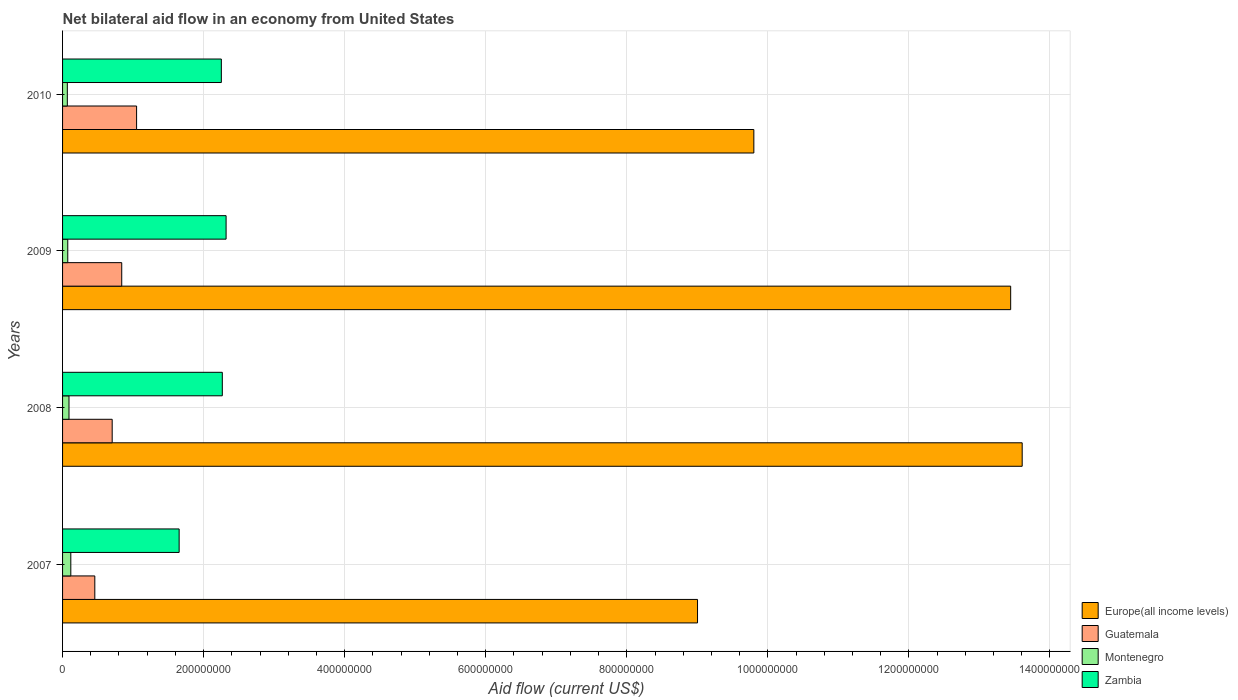How many different coloured bars are there?
Provide a succinct answer. 4. Are the number of bars per tick equal to the number of legend labels?
Make the answer very short. Yes. Are the number of bars on each tick of the Y-axis equal?
Make the answer very short. Yes. How many bars are there on the 4th tick from the bottom?
Your answer should be very brief. 4. What is the net bilateral aid flow in Zambia in 2010?
Keep it short and to the point. 2.25e+08. Across all years, what is the maximum net bilateral aid flow in Guatemala?
Make the answer very short. 1.05e+08. Across all years, what is the minimum net bilateral aid flow in Zambia?
Provide a succinct answer. 1.65e+08. In which year was the net bilateral aid flow in Guatemala minimum?
Provide a short and direct response. 2007. What is the total net bilateral aid flow in Guatemala in the graph?
Offer a terse response. 3.05e+08. What is the difference between the net bilateral aid flow in Guatemala in 2007 and that in 2009?
Ensure brevity in your answer.  -3.82e+07. What is the difference between the net bilateral aid flow in Montenegro in 2009 and the net bilateral aid flow in Guatemala in 2007?
Your answer should be very brief. -3.83e+07. What is the average net bilateral aid flow in Europe(all income levels) per year?
Your answer should be very brief. 1.15e+09. In the year 2009, what is the difference between the net bilateral aid flow in Zambia and net bilateral aid flow in Montenegro?
Offer a terse response. 2.24e+08. In how many years, is the net bilateral aid flow in Europe(all income levels) greater than 360000000 US$?
Your answer should be compact. 4. What is the ratio of the net bilateral aid flow in Montenegro in 2007 to that in 2008?
Ensure brevity in your answer.  1.28. Is the net bilateral aid flow in Montenegro in 2008 less than that in 2010?
Offer a terse response. No. Is the difference between the net bilateral aid flow in Zambia in 2007 and 2009 greater than the difference between the net bilateral aid flow in Montenegro in 2007 and 2009?
Make the answer very short. No. What is the difference between the highest and the second highest net bilateral aid flow in Montenegro?
Keep it short and to the point. 2.57e+06. What is the difference between the highest and the lowest net bilateral aid flow in Zambia?
Provide a short and direct response. 6.66e+07. In how many years, is the net bilateral aid flow in Zambia greater than the average net bilateral aid flow in Zambia taken over all years?
Give a very brief answer. 3. What does the 4th bar from the top in 2009 represents?
Your answer should be compact. Europe(all income levels). What does the 3rd bar from the bottom in 2009 represents?
Your response must be concise. Montenegro. Is it the case that in every year, the sum of the net bilateral aid flow in Guatemala and net bilateral aid flow in Zambia is greater than the net bilateral aid flow in Montenegro?
Make the answer very short. Yes. Are all the bars in the graph horizontal?
Your response must be concise. Yes. Does the graph contain any zero values?
Provide a succinct answer. No. What is the title of the graph?
Ensure brevity in your answer.  Net bilateral aid flow in an economy from United States. Does "Slovak Republic" appear as one of the legend labels in the graph?
Keep it short and to the point. No. What is the label or title of the X-axis?
Your answer should be compact. Aid flow (current US$). What is the Aid flow (current US$) of Europe(all income levels) in 2007?
Give a very brief answer. 9.00e+08. What is the Aid flow (current US$) in Guatemala in 2007?
Make the answer very short. 4.57e+07. What is the Aid flow (current US$) of Montenegro in 2007?
Provide a short and direct response. 1.17e+07. What is the Aid flow (current US$) in Zambia in 2007?
Make the answer very short. 1.65e+08. What is the Aid flow (current US$) in Europe(all income levels) in 2008?
Ensure brevity in your answer.  1.36e+09. What is the Aid flow (current US$) of Guatemala in 2008?
Your answer should be compact. 7.04e+07. What is the Aid flow (current US$) in Montenegro in 2008?
Keep it short and to the point. 9.12e+06. What is the Aid flow (current US$) of Zambia in 2008?
Provide a short and direct response. 2.26e+08. What is the Aid flow (current US$) of Europe(all income levels) in 2009?
Your answer should be very brief. 1.34e+09. What is the Aid flow (current US$) in Guatemala in 2009?
Your answer should be very brief. 8.39e+07. What is the Aid flow (current US$) in Montenegro in 2009?
Ensure brevity in your answer.  7.38e+06. What is the Aid flow (current US$) in Zambia in 2009?
Make the answer very short. 2.32e+08. What is the Aid flow (current US$) of Europe(all income levels) in 2010?
Your answer should be compact. 9.80e+08. What is the Aid flow (current US$) in Guatemala in 2010?
Make the answer very short. 1.05e+08. What is the Aid flow (current US$) in Montenegro in 2010?
Your response must be concise. 6.75e+06. What is the Aid flow (current US$) in Zambia in 2010?
Offer a terse response. 2.25e+08. Across all years, what is the maximum Aid flow (current US$) in Europe(all income levels)?
Offer a terse response. 1.36e+09. Across all years, what is the maximum Aid flow (current US$) in Guatemala?
Ensure brevity in your answer.  1.05e+08. Across all years, what is the maximum Aid flow (current US$) of Montenegro?
Offer a very short reply. 1.17e+07. Across all years, what is the maximum Aid flow (current US$) of Zambia?
Your response must be concise. 2.32e+08. Across all years, what is the minimum Aid flow (current US$) in Europe(all income levels)?
Offer a very short reply. 9.00e+08. Across all years, what is the minimum Aid flow (current US$) of Guatemala?
Ensure brevity in your answer.  4.57e+07. Across all years, what is the minimum Aid flow (current US$) in Montenegro?
Give a very brief answer. 6.75e+06. Across all years, what is the minimum Aid flow (current US$) of Zambia?
Keep it short and to the point. 1.65e+08. What is the total Aid flow (current US$) of Europe(all income levels) in the graph?
Provide a succinct answer. 4.59e+09. What is the total Aid flow (current US$) of Guatemala in the graph?
Your response must be concise. 3.05e+08. What is the total Aid flow (current US$) of Montenegro in the graph?
Keep it short and to the point. 3.49e+07. What is the total Aid flow (current US$) of Zambia in the graph?
Your response must be concise. 8.49e+08. What is the difference between the Aid flow (current US$) in Europe(all income levels) in 2007 and that in 2008?
Your answer should be compact. -4.60e+08. What is the difference between the Aid flow (current US$) of Guatemala in 2007 and that in 2008?
Your answer should be compact. -2.46e+07. What is the difference between the Aid flow (current US$) of Montenegro in 2007 and that in 2008?
Your answer should be very brief. 2.57e+06. What is the difference between the Aid flow (current US$) in Zambia in 2007 and that in 2008?
Provide a short and direct response. -6.12e+07. What is the difference between the Aid flow (current US$) in Europe(all income levels) in 2007 and that in 2009?
Ensure brevity in your answer.  -4.44e+08. What is the difference between the Aid flow (current US$) in Guatemala in 2007 and that in 2009?
Keep it short and to the point. -3.82e+07. What is the difference between the Aid flow (current US$) of Montenegro in 2007 and that in 2009?
Keep it short and to the point. 4.31e+06. What is the difference between the Aid flow (current US$) of Zambia in 2007 and that in 2009?
Give a very brief answer. -6.66e+07. What is the difference between the Aid flow (current US$) in Europe(all income levels) in 2007 and that in 2010?
Provide a succinct answer. -7.98e+07. What is the difference between the Aid flow (current US$) in Guatemala in 2007 and that in 2010?
Offer a terse response. -5.92e+07. What is the difference between the Aid flow (current US$) in Montenegro in 2007 and that in 2010?
Ensure brevity in your answer.  4.94e+06. What is the difference between the Aid flow (current US$) of Zambia in 2007 and that in 2010?
Make the answer very short. -5.98e+07. What is the difference between the Aid flow (current US$) of Europe(all income levels) in 2008 and that in 2009?
Your response must be concise. 1.63e+07. What is the difference between the Aid flow (current US$) in Guatemala in 2008 and that in 2009?
Your answer should be compact. -1.35e+07. What is the difference between the Aid flow (current US$) of Montenegro in 2008 and that in 2009?
Offer a terse response. 1.74e+06. What is the difference between the Aid flow (current US$) in Zambia in 2008 and that in 2009?
Your response must be concise. -5.37e+06. What is the difference between the Aid flow (current US$) of Europe(all income levels) in 2008 and that in 2010?
Ensure brevity in your answer.  3.80e+08. What is the difference between the Aid flow (current US$) of Guatemala in 2008 and that in 2010?
Make the answer very short. -3.46e+07. What is the difference between the Aid flow (current US$) of Montenegro in 2008 and that in 2010?
Give a very brief answer. 2.37e+06. What is the difference between the Aid flow (current US$) of Zambia in 2008 and that in 2010?
Your answer should be very brief. 1.37e+06. What is the difference between the Aid flow (current US$) of Europe(all income levels) in 2009 and that in 2010?
Keep it short and to the point. 3.64e+08. What is the difference between the Aid flow (current US$) of Guatemala in 2009 and that in 2010?
Make the answer very short. -2.11e+07. What is the difference between the Aid flow (current US$) in Montenegro in 2009 and that in 2010?
Your answer should be very brief. 6.30e+05. What is the difference between the Aid flow (current US$) of Zambia in 2009 and that in 2010?
Keep it short and to the point. 6.74e+06. What is the difference between the Aid flow (current US$) in Europe(all income levels) in 2007 and the Aid flow (current US$) in Guatemala in 2008?
Offer a very short reply. 8.30e+08. What is the difference between the Aid flow (current US$) of Europe(all income levels) in 2007 and the Aid flow (current US$) of Montenegro in 2008?
Offer a very short reply. 8.91e+08. What is the difference between the Aid flow (current US$) in Europe(all income levels) in 2007 and the Aid flow (current US$) in Zambia in 2008?
Offer a terse response. 6.74e+08. What is the difference between the Aid flow (current US$) of Guatemala in 2007 and the Aid flow (current US$) of Montenegro in 2008?
Ensure brevity in your answer.  3.66e+07. What is the difference between the Aid flow (current US$) of Guatemala in 2007 and the Aid flow (current US$) of Zambia in 2008?
Keep it short and to the point. -1.81e+08. What is the difference between the Aid flow (current US$) in Montenegro in 2007 and the Aid flow (current US$) in Zambia in 2008?
Make the answer very short. -2.15e+08. What is the difference between the Aid flow (current US$) of Europe(all income levels) in 2007 and the Aid flow (current US$) of Guatemala in 2009?
Your response must be concise. 8.16e+08. What is the difference between the Aid flow (current US$) in Europe(all income levels) in 2007 and the Aid flow (current US$) in Montenegro in 2009?
Ensure brevity in your answer.  8.93e+08. What is the difference between the Aid flow (current US$) of Europe(all income levels) in 2007 and the Aid flow (current US$) of Zambia in 2009?
Provide a succinct answer. 6.68e+08. What is the difference between the Aid flow (current US$) in Guatemala in 2007 and the Aid flow (current US$) in Montenegro in 2009?
Give a very brief answer. 3.83e+07. What is the difference between the Aid flow (current US$) of Guatemala in 2007 and the Aid flow (current US$) of Zambia in 2009?
Offer a terse response. -1.86e+08. What is the difference between the Aid flow (current US$) in Montenegro in 2007 and the Aid flow (current US$) in Zambia in 2009?
Your answer should be very brief. -2.20e+08. What is the difference between the Aid flow (current US$) of Europe(all income levels) in 2007 and the Aid flow (current US$) of Guatemala in 2010?
Offer a terse response. 7.95e+08. What is the difference between the Aid flow (current US$) in Europe(all income levels) in 2007 and the Aid flow (current US$) in Montenegro in 2010?
Make the answer very short. 8.94e+08. What is the difference between the Aid flow (current US$) of Europe(all income levels) in 2007 and the Aid flow (current US$) of Zambia in 2010?
Your answer should be compact. 6.75e+08. What is the difference between the Aid flow (current US$) in Guatemala in 2007 and the Aid flow (current US$) in Montenegro in 2010?
Your answer should be very brief. 3.90e+07. What is the difference between the Aid flow (current US$) of Guatemala in 2007 and the Aid flow (current US$) of Zambia in 2010?
Provide a succinct answer. -1.79e+08. What is the difference between the Aid flow (current US$) of Montenegro in 2007 and the Aid flow (current US$) of Zambia in 2010?
Offer a terse response. -2.13e+08. What is the difference between the Aid flow (current US$) of Europe(all income levels) in 2008 and the Aid flow (current US$) of Guatemala in 2009?
Your answer should be very brief. 1.28e+09. What is the difference between the Aid flow (current US$) in Europe(all income levels) in 2008 and the Aid flow (current US$) in Montenegro in 2009?
Offer a very short reply. 1.35e+09. What is the difference between the Aid flow (current US$) of Europe(all income levels) in 2008 and the Aid flow (current US$) of Zambia in 2009?
Provide a succinct answer. 1.13e+09. What is the difference between the Aid flow (current US$) in Guatemala in 2008 and the Aid flow (current US$) in Montenegro in 2009?
Give a very brief answer. 6.30e+07. What is the difference between the Aid flow (current US$) of Guatemala in 2008 and the Aid flow (current US$) of Zambia in 2009?
Provide a succinct answer. -1.62e+08. What is the difference between the Aid flow (current US$) of Montenegro in 2008 and the Aid flow (current US$) of Zambia in 2009?
Give a very brief answer. -2.23e+08. What is the difference between the Aid flow (current US$) of Europe(all income levels) in 2008 and the Aid flow (current US$) of Guatemala in 2010?
Ensure brevity in your answer.  1.26e+09. What is the difference between the Aid flow (current US$) in Europe(all income levels) in 2008 and the Aid flow (current US$) in Montenegro in 2010?
Give a very brief answer. 1.35e+09. What is the difference between the Aid flow (current US$) in Europe(all income levels) in 2008 and the Aid flow (current US$) in Zambia in 2010?
Offer a very short reply. 1.14e+09. What is the difference between the Aid flow (current US$) in Guatemala in 2008 and the Aid flow (current US$) in Montenegro in 2010?
Give a very brief answer. 6.36e+07. What is the difference between the Aid flow (current US$) in Guatemala in 2008 and the Aid flow (current US$) in Zambia in 2010?
Your response must be concise. -1.55e+08. What is the difference between the Aid flow (current US$) in Montenegro in 2008 and the Aid flow (current US$) in Zambia in 2010?
Your response must be concise. -2.16e+08. What is the difference between the Aid flow (current US$) in Europe(all income levels) in 2009 and the Aid flow (current US$) in Guatemala in 2010?
Offer a terse response. 1.24e+09. What is the difference between the Aid flow (current US$) of Europe(all income levels) in 2009 and the Aid flow (current US$) of Montenegro in 2010?
Keep it short and to the point. 1.34e+09. What is the difference between the Aid flow (current US$) in Europe(all income levels) in 2009 and the Aid flow (current US$) in Zambia in 2010?
Offer a very short reply. 1.12e+09. What is the difference between the Aid flow (current US$) in Guatemala in 2009 and the Aid flow (current US$) in Montenegro in 2010?
Provide a succinct answer. 7.71e+07. What is the difference between the Aid flow (current US$) of Guatemala in 2009 and the Aid flow (current US$) of Zambia in 2010?
Provide a short and direct response. -1.41e+08. What is the difference between the Aid flow (current US$) in Montenegro in 2009 and the Aid flow (current US$) in Zambia in 2010?
Keep it short and to the point. -2.18e+08. What is the average Aid flow (current US$) in Europe(all income levels) per year?
Keep it short and to the point. 1.15e+09. What is the average Aid flow (current US$) in Guatemala per year?
Give a very brief answer. 7.62e+07. What is the average Aid flow (current US$) of Montenegro per year?
Provide a short and direct response. 8.74e+06. What is the average Aid flow (current US$) in Zambia per year?
Provide a succinct answer. 2.12e+08. In the year 2007, what is the difference between the Aid flow (current US$) in Europe(all income levels) and Aid flow (current US$) in Guatemala?
Offer a very short reply. 8.55e+08. In the year 2007, what is the difference between the Aid flow (current US$) of Europe(all income levels) and Aid flow (current US$) of Montenegro?
Offer a very short reply. 8.89e+08. In the year 2007, what is the difference between the Aid flow (current US$) of Europe(all income levels) and Aid flow (current US$) of Zambia?
Provide a succinct answer. 7.35e+08. In the year 2007, what is the difference between the Aid flow (current US$) of Guatemala and Aid flow (current US$) of Montenegro?
Your answer should be very brief. 3.40e+07. In the year 2007, what is the difference between the Aid flow (current US$) of Guatemala and Aid flow (current US$) of Zambia?
Provide a succinct answer. -1.20e+08. In the year 2007, what is the difference between the Aid flow (current US$) in Montenegro and Aid flow (current US$) in Zambia?
Provide a succinct answer. -1.54e+08. In the year 2008, what is the difference between the Aid flow (current US$) in Europe(all income levels) and Aid flow (current US$) in Guatemala?
Provide a short and direct response. 1.29e+09. In the year 2008, what is the difference between the Aid flow (current US$) in Europe(all income levels) and Aid flow (current US$) in Montenegro?
Offer a terse response. 1.35e+09. In the year 2008, what is the difference between the Aid flow (current US$) in Europe(all income levels) and Aid flow (current US$) in Zambia?
Your answer should be compact. 1.13e+09. In the year 2008, what is the difference between the Aid flow (current US$) in Guatemala and Aid flow (current US$) in Montenegro?
Give a very brief answer. 6.12e+07. In the year 2008, what is the difference between the Aid flow (current US$) in Guatemala and Aid flow (current US$) in Zambia?
Make the answer very short. -1.56e+08. In the year 2008, what is the difference between the Aid flow (current US$) in Montenegro and Aid flow (current US$) in Zambia?
Provide a short and direct response. -2.17e+08. In the year 2009, what is the difference between the Aid flow (current US$) in Europe(all income levels) and Aid flow (current US$) in Guatemala?
Make the answer very short. 1.26e+09. In the year 2009, what is the difference between the Aid flow (current US$) in Europe(all income levels) and Aid flow (current US$) in Montenegro?
Offer a terse response. 1.34e+09. In the year 2009, what is the difference between the Aid flow (current US$) in Europe(all income levels) and Aid flow (current US$) in Zambia?
Your answer should be very brief. 1.11e+09. In the year 2009, what is the difference between the Aid flow (current US$) of Guatemala and Aid flow (current US$) of Montenegro?
Your answer should be compact. 7.65e+07. In the year 2009, what is the difference between the Aid flow (current US$) in Guatemala and Aid flow (current US$) in Zambia?
Provide a succinct answer. -1.48e+08. In the year 2009, what is the difference between the Aid flow (current US$) in Montenegro and Aid flow (current US$) in Zambia?
Your response must be concise. -2.24e+08. In the year 2010, what is the difference between the Aid flow (current US$) in Europe(all income levels) and Aid flow (current US$) in Guatemala?
Offer a very short reply. 8.75e+08. In the year 2010, what is the difference between the Aid flow (current US$) in Europe(all income levels) and Aid flow (current US$) in Montenegro?
Your response must be concise. 9.73e+08. In the year 2010, what is the difference between the Aid flow (current US$) of Europe(all income levels) and Aid flow (current US$) of Zambia?
Provide a succinct answer. 7.55e+08. In the year 2010, what is the difference between the Aid flow (current US$) of Guatemala and Aid flow (current US$) of Montenegro?
Offer a very short reply. 9.82e+07. In the year 2010, what is the difference between the Aid flow (current US$) in Guatemala and Aid flow (current US$) in Zambia?
Keep it short and to the point. -1.20e+08. In the year 2010, what is the difference between the Aid flow (current US$) of Montenegro and Aid flow (current US$) of Zambia?
Give a very brief answer. -2.18e+08. What is the ratio of the Aid flow (current US$) of Europe(all income levels) in 2007 to that in 2008?
Provide a short and direct response. 0.66. What is the ratio of the Aid flow (current US$) of Guatemala in 2007 to that in 2008?
Provide a succinct answer. 0.65. What is the ratio of the Aid flow (current US$) of Montenegro in 2007 to that in 2008?
Offer a very short reply. 1.28. What is the ratio of the Aid flow (current US$) in Zambia in 2007 to that in 2008?
Your answer should be very brief. 0.73. What is the ratio of the Aid flow (current US$) of Europe(all income levels) in 2007 to that in 2009?
Your answer should be compact. 0.67. What is the ratio of the Aid flow (current US$) in Guatemala in 2007 to that in 2009?
Keep it short and to the point. 0.54. What is the ratio of the Aid flow (current US$) of Montenegro in 2007 to that in 2009?
Offer a terse response. 1.58. What is the ratio of the Aid flow (current US$) of Zambia in 2007 to that in 2009?
Keep it short and to the point. 0.71. What is the ratio of the Aid flow (current US$) of Europe(all income levels) in 2007 to that in 2010?
Offer a terse response. 0.92. What is the ratio of the Aid flow (current US$) of Guatemala in 2007 to that in 2010?
Your answer should be compact. 0.44. What is the ratio of the Aid flow (current US$) of Montenegro in 2007 to that in 2010?
Keep it short and to the point. 1.73. What is the ratio of the Aid flow (current US$) in Zambia in 2007 to that in 2010?
Your answer should be very brief. 0.73. What is the ratio of the Aid flow (current US$) in Europe(all income levels) in 2008 to that in 2009?
Make the answer very short. 1.01. What is the ratio of the Aid flow (current US$) of Guatemala in 2008 to that in 2009?
Provide a succinct answer. 0.84. What is the ratio of the Aid flow (current US$) of Montenegro in 2008 to that in 2009?
Keep it short and to the point. 1.24. What is the ratio of the Aid flow (current US$) in Zambia in 2008 to that in 2009?
Offer a terse response. 0.98. What is the ratio of the Aid flow (current US$) in Europe(all income levels) in 2008 to that in 2010?
Ensure brevity in your answer.  1.39. What is the ratio of the Aid flow (current US$) of Guatemala in 2008 to that in 2010?
Provide a short and direct response. 0.67. What is the ratio of the Aid flow (current US$) in Montenegro in 2008 to that in 2010?
Offer a terse response. 1.35. What is the ratio of the Aid flow (current US$) of Europe(all income levels) in 2009 to that in 2010?
Your answer should be compact. 1.37. What is the ratio of the Aid flow (current US$) of Guatemala in 2009 to that in 2010?
Provide a short and direct response. 0.8. What is the ratio of the Aid flow (current US$) in Montenegro in 2009 to that in 2010?
Provide a short and direct response. 1.09. What is the ratio of the Aid flow (current US$) in Zambia in 2009 to that in 2010?
Your answer should be very brief. 1.03. What is the difference between the highest and the second highest Aid flow (current US$) of Europe(all income levels)?
Give a very brief answer. 1.63e+07. What is the difference between the highest and the second highest Aid flow (current US$) in Guatemala?
Make the answer very short. 2.11e+07. What is the difference between the highest and the second highest Aid flow (current US$) in Montenegro?
Give a very brief answer. 2.57e+06. What is the difference between the highest and the second highest Aid flow (current US$) of Zambia?
Give a very brief answer. 5.37e+06. What is the difference between the highest and the lowest Aid flow (current US$) in Europe(all income levels)?
Make the answer very short. 4.60e+08. What is the difference between the highest and the lowest Aid flow (current US$) of Guatemala?
Provide a succinct answer. 5.92e+07. What is the difference between the highest and the lowest Aid flow (current US$) of Montenegro?
Offer a terse response. 4.94e+06. What is the difference between the highest and the lowest Aid flow (current US$) in Zambia?
Make the answer very short. 6.66e+07. 